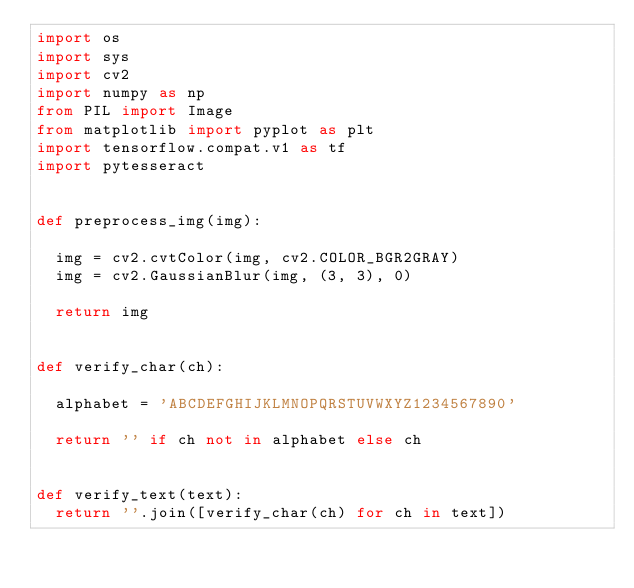<code> <loc_0><loc_0><loc_500><loc_500><_Python_>import os
import sys
import cv2
import numpy as np
from PIL import Image
from matplotlib import pyplot as plt
import tensorflow.compat.v1 as tf
import pytesseract


def preprocess_img(img):

	img = cv2.cvtColor(img, cv2.COLOR_BGR2GRAY)
	img = cv2.GaussianBlur(img, (3, 3), 0)

	return img


def verify_char(ch):

	alphabet = 'ABCDEFGHIJKLMNOPQRSTUVWXYZ1234567890'
	
	return '' if ch not in alphabet else ch


def verify_text(text):
	return ''.join([verify_char(ch) for ch in text])

</code> 